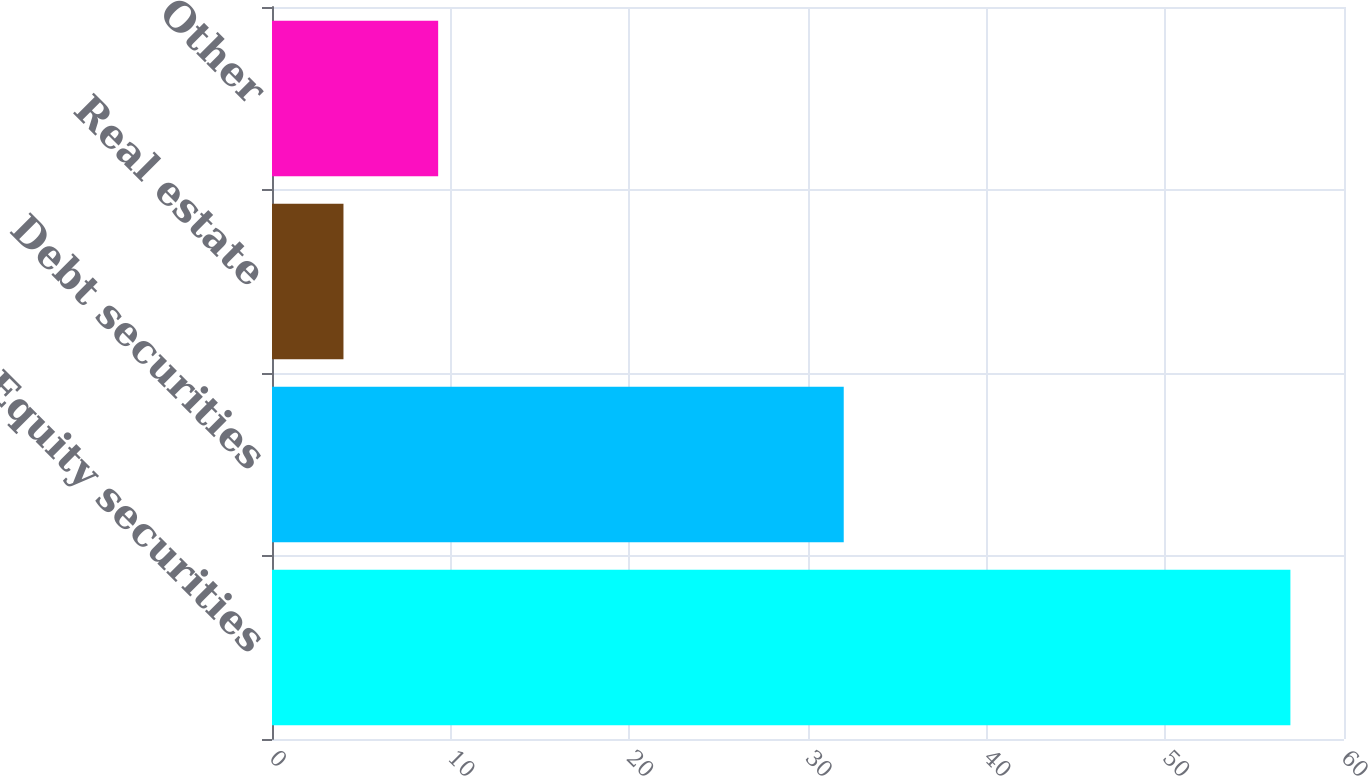<chart> <loc_0><loc_0><loc_500><loc_500><bar_chart><fcel>Equity securities<fcel>Debt securities<fcel>Real estate<fcel>Other<nl><fcel>57<fcel>32<fcel>4<fcel>9.3<nl></chart> 